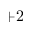<formula> <loc_0><loc_0><loc_500><loc_500>+ 2</formula> 